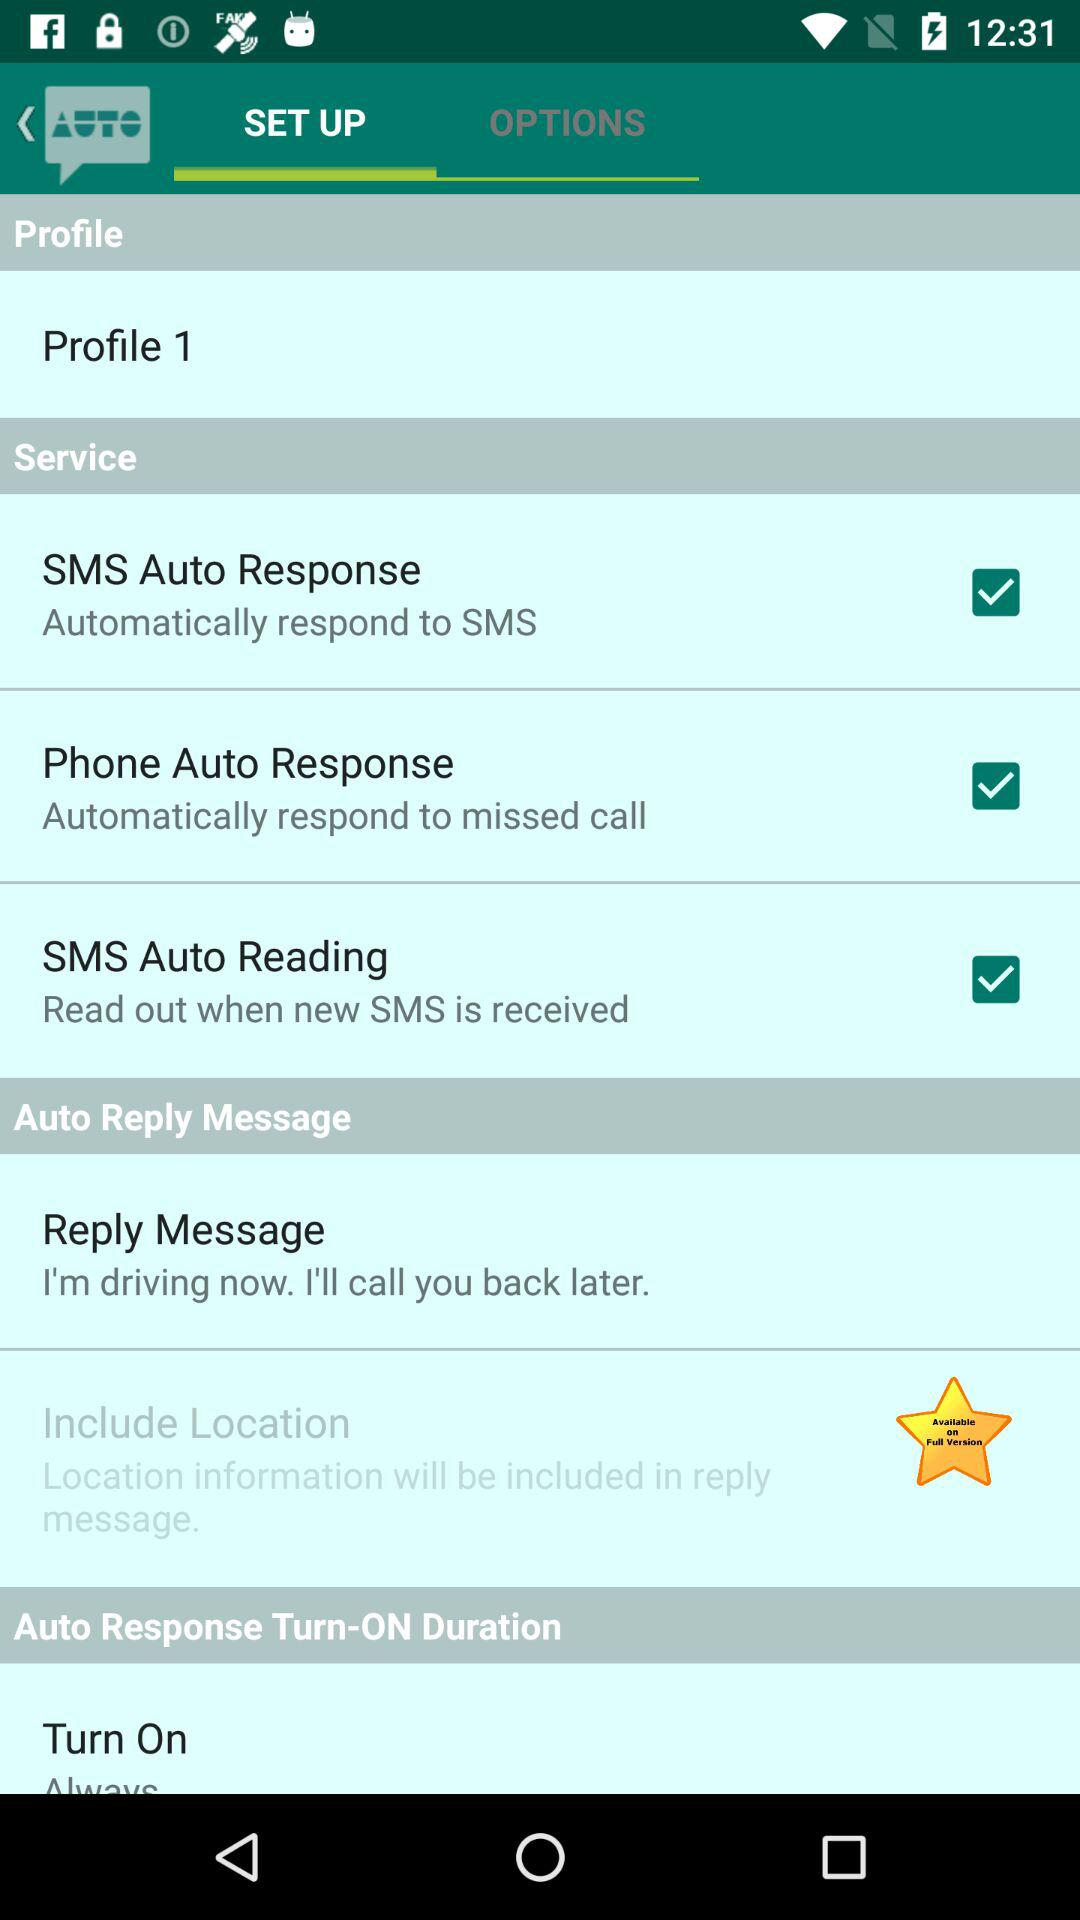Which tab is currently selected? The currently selected tab is "SET UP". 